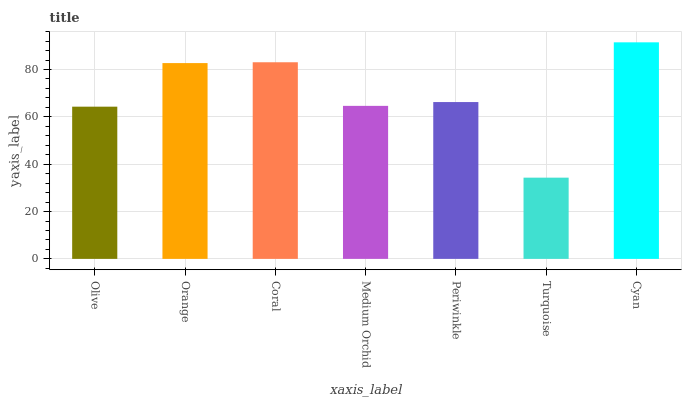Is Turquoise the minimum?
Answer yes or no. Yes. Is Cyan the maximum?
Answer yes or no. Yes. Is Orange the minimum?
Answer yes or no. No. Is Orange the maximum?
Answer yes or no. No. Is Orange greater than Olive?
Answer yes or no. Yes. Is Olive less than Orange?
Answer yes or no. Yes. Is Olive greater than Orange?
Answer yes or no. No. Is Orange less than Olive?
Answer yes or no. No. Is Periwinkle the high median?
Answer yes or no. Yes. Is Periwinkle the low median?
Answer yes or no. Yes. Is Medium Orchid the high median?
Answer yes or no. No. Is Cyan the low median?
Answer yes or no. No. 